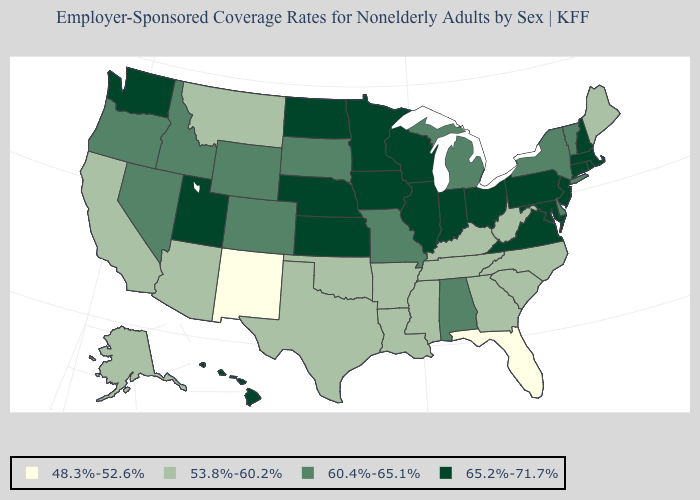Name the states that have a value in the range 53.8%-60.2%?
Keep it brief. Alaska, Arizona, Arkansas, California, Georgia, Kentucky, Louisiana, Maine, Mississippi, Montana, North Carolina, Oklahoma, South Carolina, Tennessee, Texas, West Virginia. Name the states that have a value in the range 53.8%-60.2%?
Give a very brief answer. Alaska, Arizona, Arkansas, California, Georgia, Kentucky, Louisiana, Maine, Mississippi, Montana, North Carolina, Oklahoma, South Carolina, Tennessee, Texas, West Virginia. What is the highest value in the USA?
Give a very brief answer. 65.2%-71.7%. What is the value of Mississippi?
Be succinct. 53.8%-60.2%. Does the map have missing data?
Write a very short answer. No. Name the states that have a value in the range 60.4%-65.1%?
Quick response, please. Alabama, Colorado, Delaware, Idaho, Michigan, Missouri, Nevada, New York, Oregon, South Dakota, Vermont, Wyoming. Does New Mexico have the lowest value in the USA?
Write a very short answer. Yes. What is the lowest value in the South?
Concise answer only. 48.3%-52.6%. Does Wyoming have the lowest value in the USA?
Keep it brief. No. What is the value of Colorado?
Be succinct. 60.4%-65.1%. Does New York have the highest value in the USA?
Write a very short answer. No. Name the states that have a value in the range 65.2%-71.7%?
Concise answer only. Connecticut, Hawaii, Illinois, Indiana, Iowa, Kansas, Maryland, Massachusetts, Minnesota, Nebraska, New Hampshire, New Jersey, North Dakota, Ohio, Pennsylvania, Rhode Island, Utah, Virginia, Washington, Wisconsin. Among the states that border New Mexico , which have the lowest value?
Be succinct. Arizona, Oklahoma, Texas. What is the value of Oklahoma?
Answer briefly. 53.8%-60.2%. Is the legend a continuous bar?
Be succinct. No. 